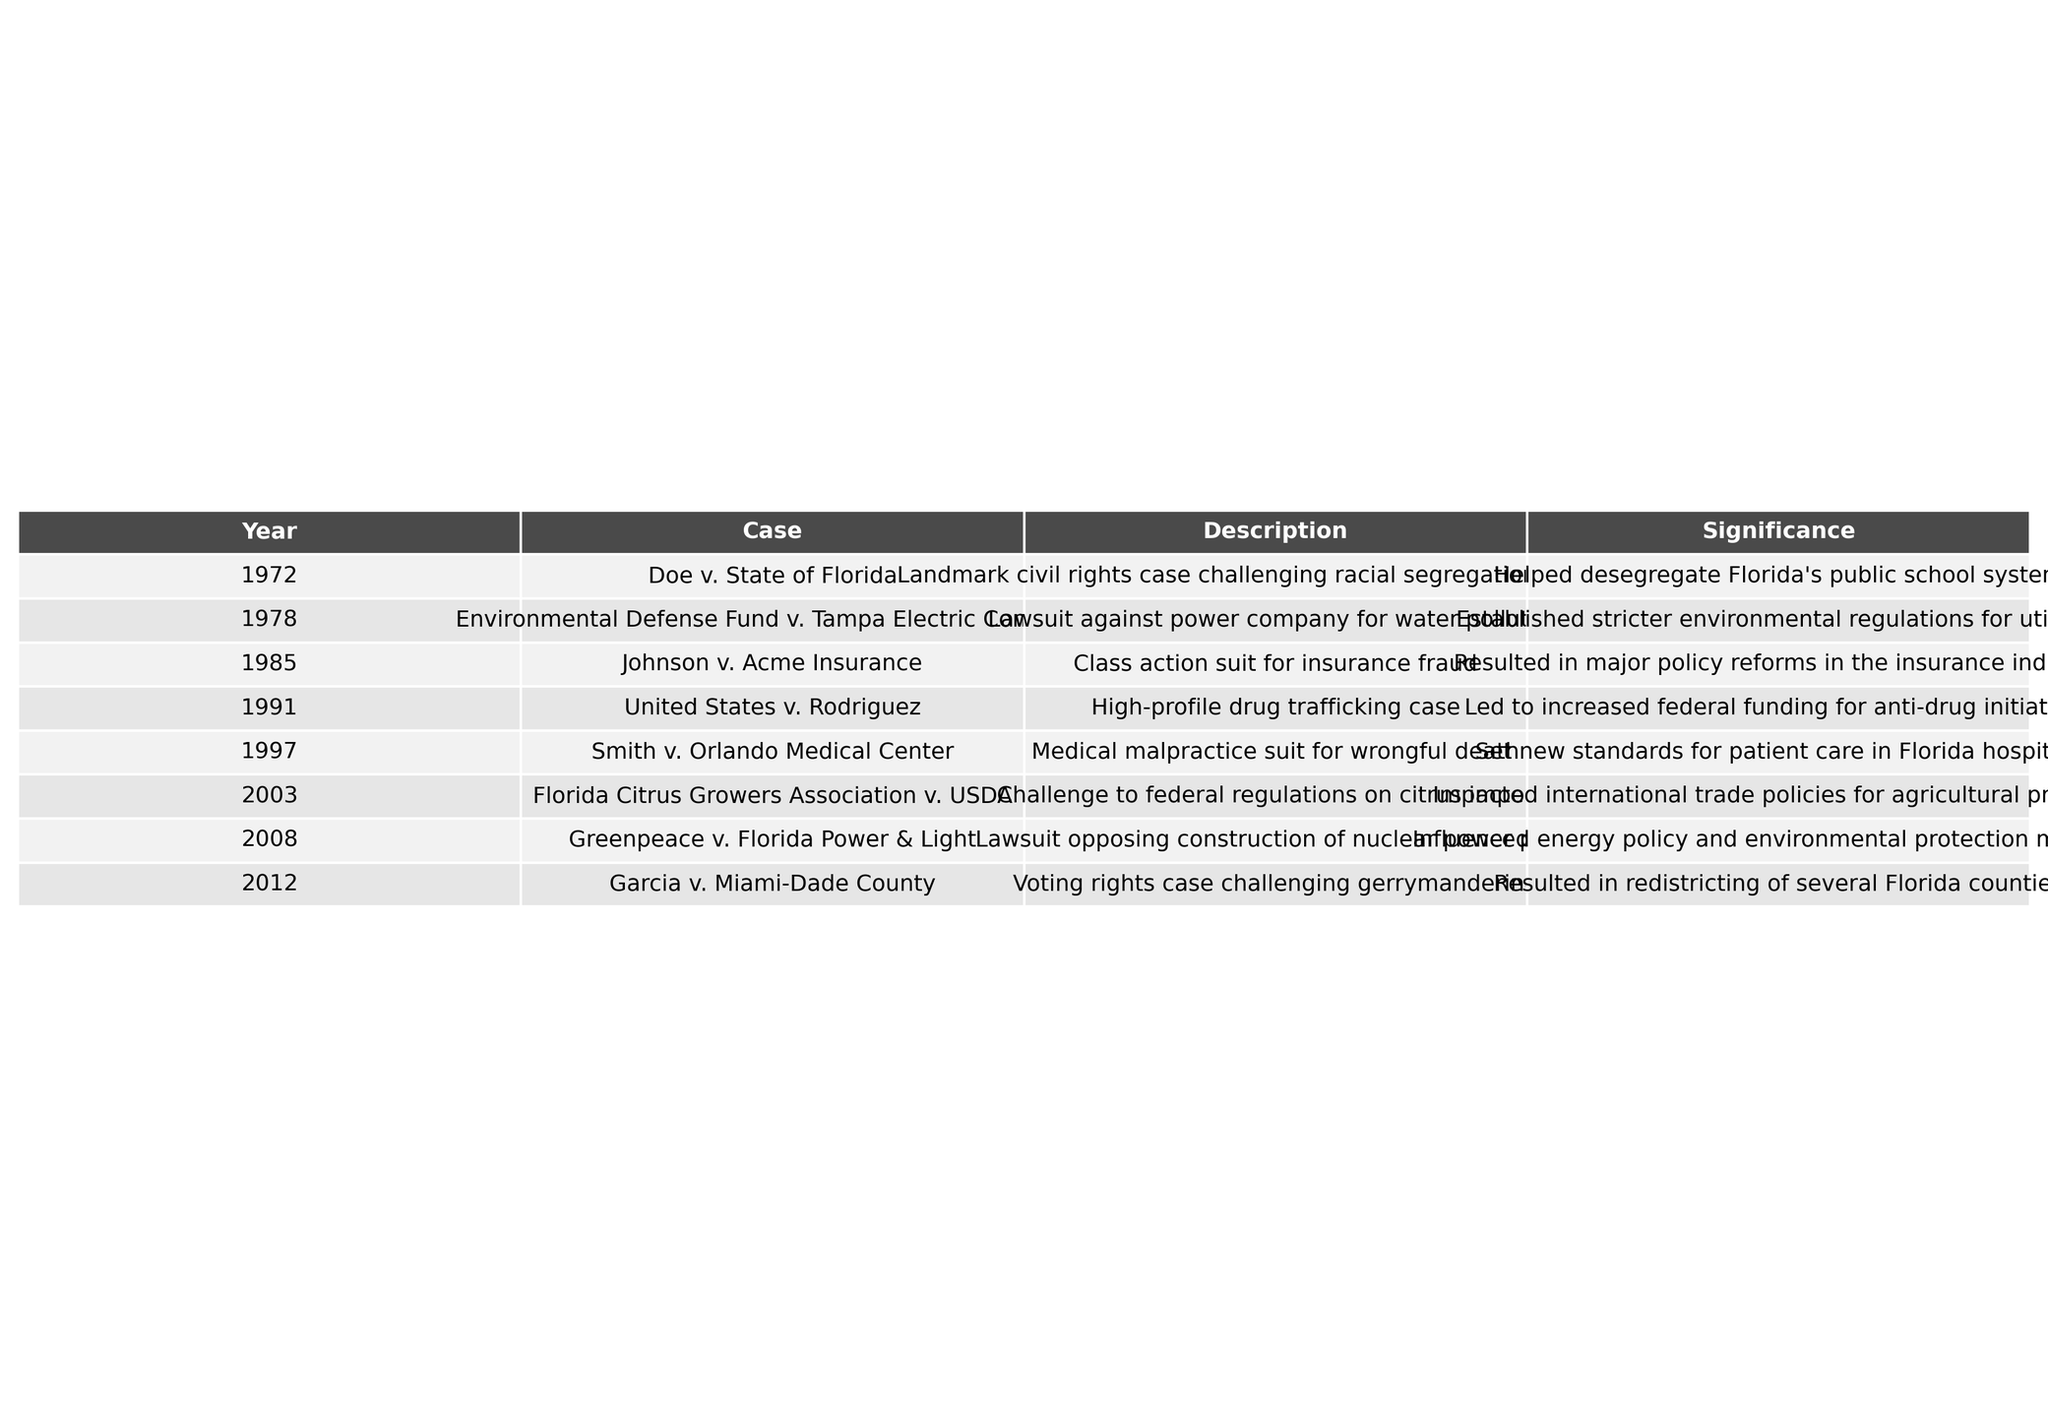What was the significance of the case Doe v. State of Florida? The case Doe v. State of Florida was significant because it challenged racial segregation in schools, leading to desegregation of Florida's public school system.
Answer: Helped desegregate Florida's public school system Which year did the case Environmental Defense Fund v. Tampa Electric Company occur? The case Environmental Defense Fund v. Tampa Electric Company took place in 1978, as indicated in the table.
Answer: 1978 How many cases did Kenneth F. Murrah handle in the 1990s? There are three cases listed in the table from the 1990s: United States v. Rodriguez (1991), Smith v. Orlando Medical Center (1997), and one more in the decade. Therefore, the total is 3.
Answer: 3 What was the outcome of the case Johnson v. Acme Insurance? The outcome of Johnson v. Acme Insurance resulted in major policy reforms in the insurance industry due to the class action suit for insurance fraud.
Answer: Major policy reforms in the insurance industry Did Kenneth F. Murrah handle any voting rights cases? Yes, he handled the case Garcia v. Miami-Dade County, which was a voting rights case challenging gerrymandering.
Answer: Yes Which case had an impact on environmental policy? The case Greenpeace v. Florida Power & Light influenced energy policy and environmental protection measures through its opposition to a nuclear power plant construction.
Answer: Greenpeace v. Florida Power & Light What were the two notable cases mentioned in the table from the year 2003? The notable case from 2003 is Florida Citrus Growers Association v. USDA, which challenged federal regulations on citrus imports. There is only one case listed for that year.
Answer: Florida Citrus Growers Association v. USDA How did the case Smith v. Orlando Medical Center change the standards of patient care? The case set new standards for patient care in Florida hospitals due to a medical malpractice suit for wrongful death.
Answer: Set new standards for patient care Which case was related to drug trafficking and what was its significance? The case United States v. Rodriguez was related to drug trafficking, and its significance was that it led to increased federal funding for anti-drug initiatives.
Answer: Increased federal funding for anti-drug initiatives What was the earlier case in the table that dealt with environmental issues? The earlier case that dealt with environmental issues is Environmental Defense Fund v. Tampa Electric Company, which occurred in 1978.
Answer: Environmental Defense Fund v. Tampa Electric Company Which case resulted in changes to redistricting in Florida? The case Garcia v. Miami-Dade County resulted in redistricting of several Florida counties due to challenges against gerrymandering.
Answer: Garcia v. Miami-Dade County 